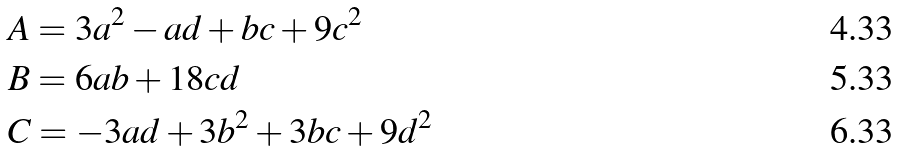Convert formula to latex. <formula><loc_0><loc_0><loc_500><loc_500>& A = 3 a ^ { 2 } - a d + b c + 9 c ^ { 2 } \\ & B = 6 a b + 1 8 c d \\ & C = - 3 a d + 3 b ^ { 2 } + 3 b c + 9 d ^ { 2 }</formula> 